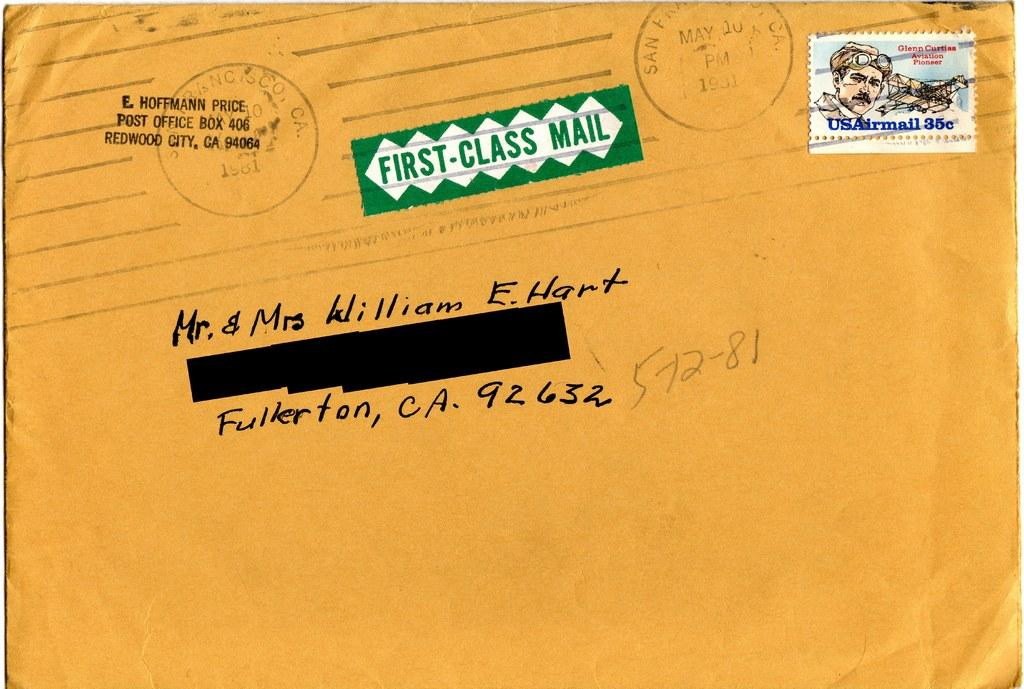<image>
Give a short and clear explanation of the subsequent image. A first class letter being mailed to Fullerton California. 